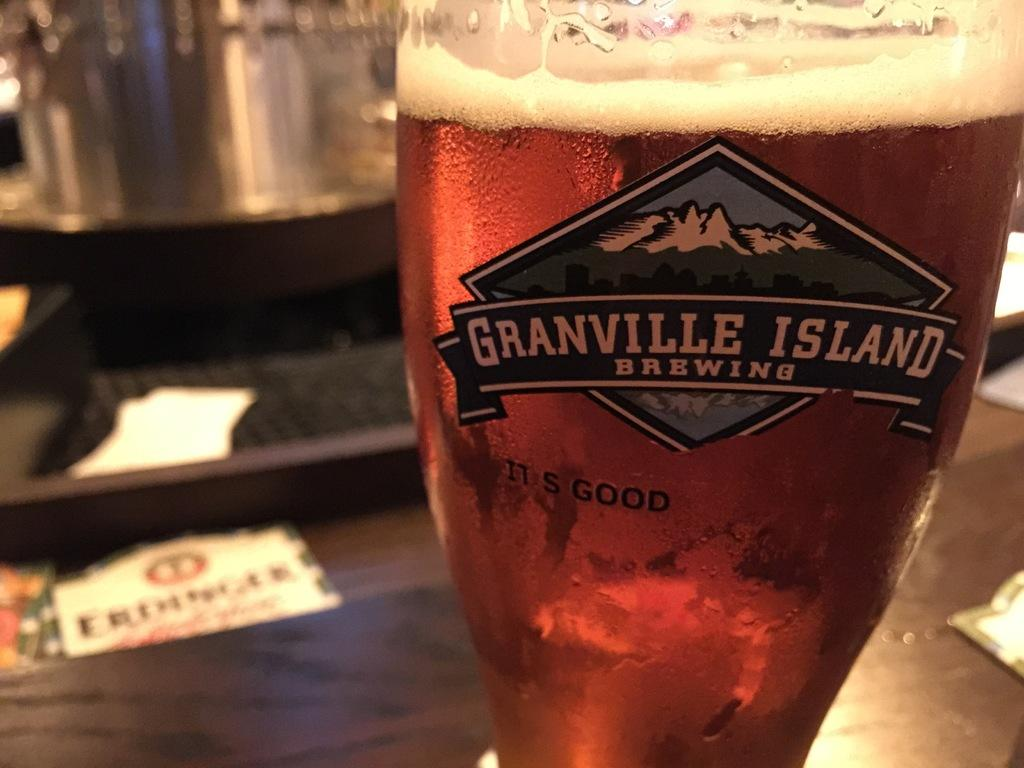<image>
Share a concise interpretation of the image provided. A glass that says Granville island brewing with beer in it 